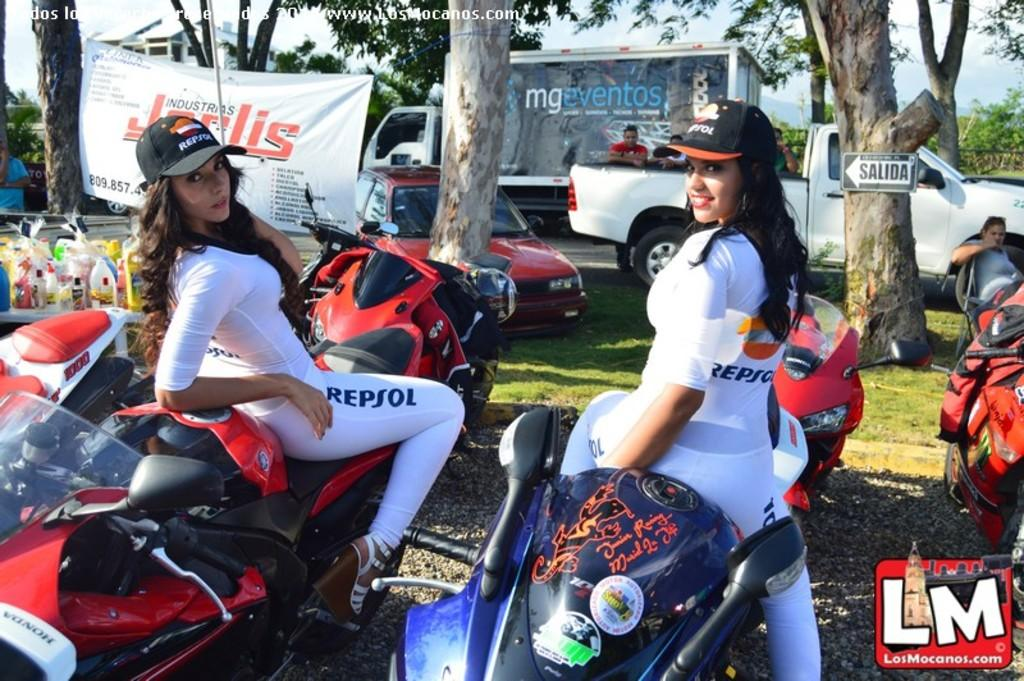How many people are in the image? There are two lady persons in the image. What are the lady persons doing in the image? The lady persons are sitting on bikes. What are the lady persons wearing in the image? Both lady persons are wearing similar dresses and caps. What can be seen in the background of the image? There are cars, trees, and a banner in the background of the image. What type of zinc is being mined in the background of the image? There is no zinc mining activity present in the image; it features two lady persons sitting on bikes and a background with cars, trees, and a banner. 